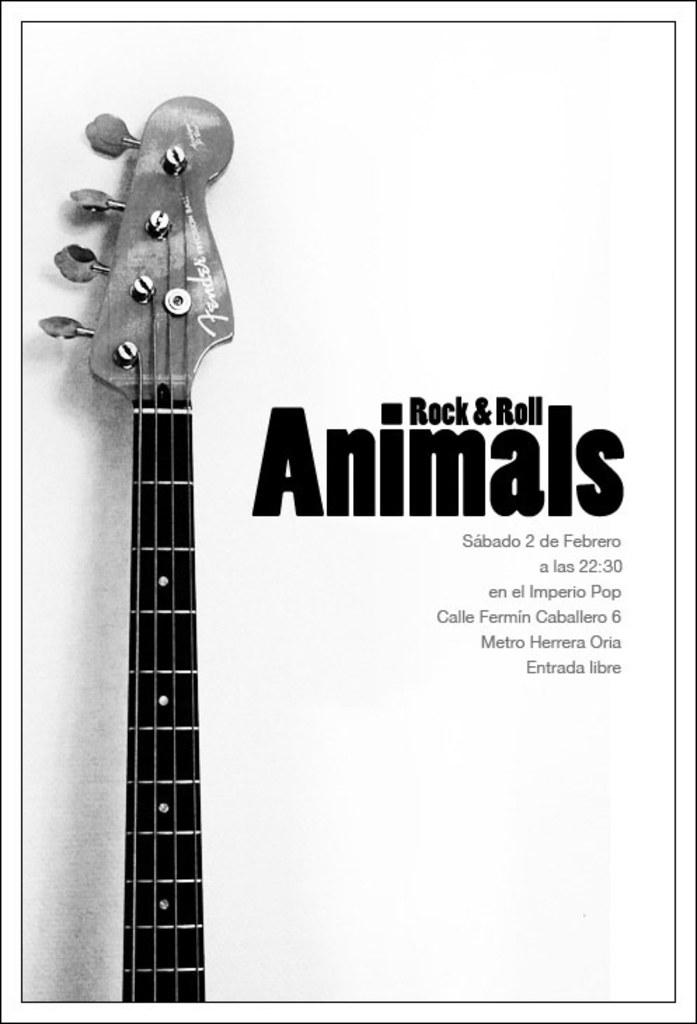What is the color scheme of the image? The image is black and white. What is the main subject of the image? There is a picture of a guitar in the image. What else is present in the image besides the guitar? There is text beside the guitar in the image. What type of mailbox is shown next to the guitar in the image? There is no mailbox present in the image; it only features a picture of a guitar and text. What emotion is expressed by the guitar in the image? The guitar is an inanimate object and cannot express emotions like hate. 